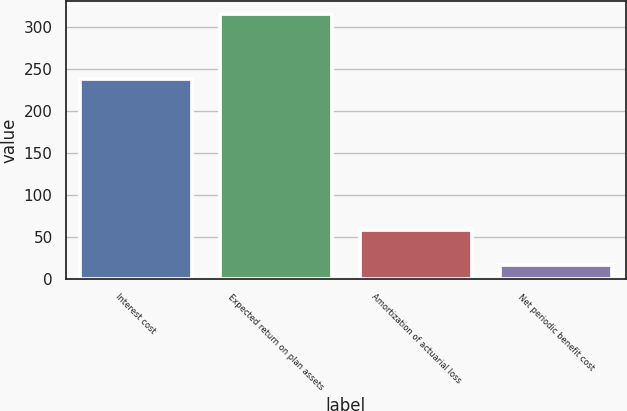Convert chart to OTSL. <chart><loc_0><loc_0><loc_500><loc_500><bar_chart><fcel>Interest cost<fcel>Expected return on plan assets<fcel>Amortization of actuarial loss<fcel>Net periodic benefit cost<nl><fcel>238<fcel>315<fcel>59<fcel>17<nl></chart> 